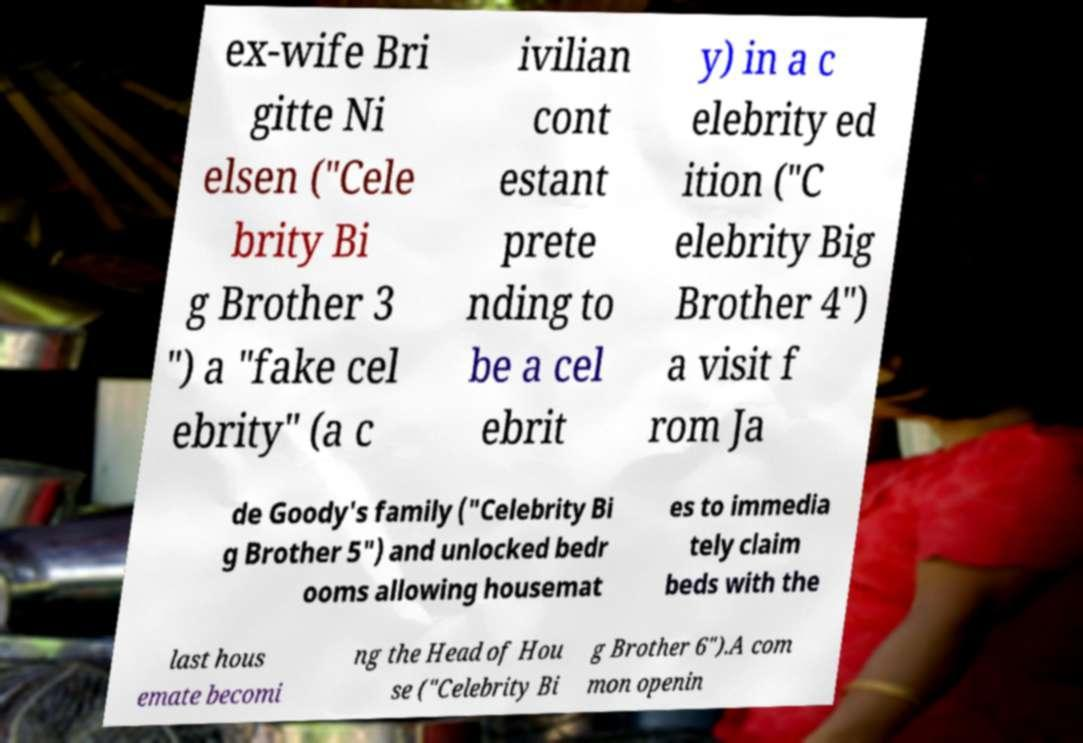Could you assist in decoding the text presented in this image and type it out clearly? ex-wife Bri gitte Ni elsen ("Cele brity Bi g Brother 3 ") a "fake cel ebrity" (a c ivilian cont estant prete nding to be a cel ebrit y) in a c elebrity ed ition ("C elebrity Big Brother 4") a visit f rom Ja de Goody's family ("Celebrity Bi g Brother 5") and unlocked bedr ooms allowing housemat es to immedia tely claim beds with the last hous emate becomi ng the Head of Hou se ("Celebrity Bi g Brother 6").A com mon openin 